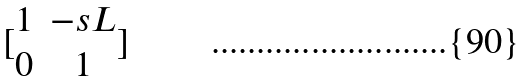<formula> <loc_0><loc_0><loc_500><loc_500>[ \begin{matrix} 1 & - s L \\ 0 & 1 \end{matrix} ]</formula> 